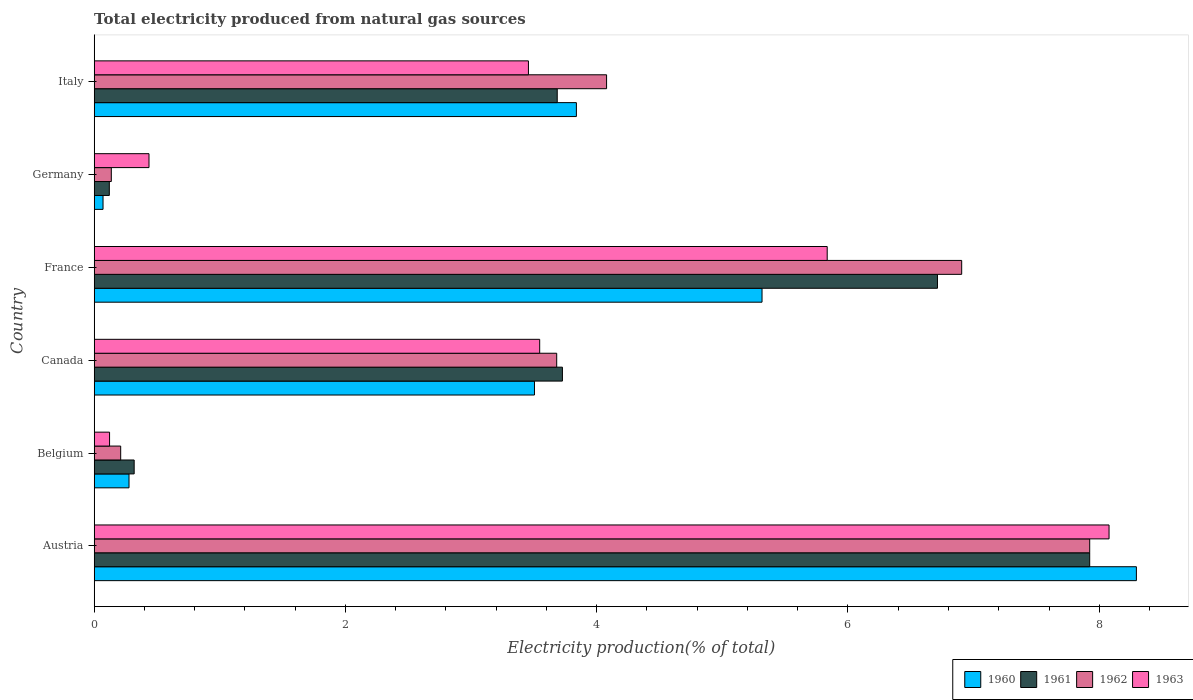How many different coloured bars are there?
Offer a terse response. 4. Are the number of bars per tick equal to the number of legend labels?
Ensure brevity in your answer.  Yes. Are the number of bars on each tick of the Y-axis equal?
Make the answer very short. Yes. In how many cases, is the number of bars for a given country not equal to the number of legend labels?
Provide a short and direct response. 0. What is the total electricity produced in 1963 in France?
Your answer should be very brief. 5.83. Across all countries, what is the maximum total electricity produced in 1962?
Offer a very short reply. 7.92. Across all countries, what is the minimum total electricity produced in 1961?
Offer a terse response. 0.12. What is the total total electricity produced in 1962 in the graph?
Offer a very short reply. 22.94. What is the difference between the total electricity produced in 1960 in Austria and that in Canada?
Keep it short and to the point. 4.79. What is the difference between the total electricity produced in 1963 in France and the total electricity produced in 1960 in Germany?
Your answer should be very brief. 5.76. What is the average total electricity produced in 1960 per country?
Your answer should be compact. 3.55. What is the difference between the total electricity produced in 1962 and total electricity produced in 1960 in Germany?
Provide a short and direct response. 0.07. What is the ratio of the total electricity produced in 1962 in Canada to that in Germany?
Your response must be concise. 27.02. Is the total electricity produced in 1960 in Canada less than that in Italy?
Offer a very short reply. Yes. What is the difference between the highest and the second highest total electricity produced in 1961?
Offer a terse response. 1.21. What is the difference between the highest and the lowest total electricity produced in 1963?
Give a very brief answer. 7.96. What does the 2nd bar from the bottom in Italy represents?
Provide a short and direct response. 1961. Is it the case that in every country, the sum of the total electricity produced in 1960 and total electricity produced in 1963 is greater than the total electricity produced in 1961?
Your response must be concise. Yes. How many countries are there in the graph?
Ensure brevity in your answer.  6. Does the graph contain any zero values?
Offer a terse response. No. How many legend labels are there?
Your answer should be very brief. 4. How are the legend labels stacked?
Ensure brevity in your answer.  Horizontal. What is the title of the graph?
Your answer should be compact. Total electricity produced from natural gas sources. What is the Electricity production(% of total) in 1960 in Austria?
Keep it short and to the point. 8.3. What is the Electricity production(% of total) in 1961 in Austria?
Ensure brevity in your answer.  7.92. What is the Electricity production(% of total) of 1962 in Austria?
Offer a very short reply. 7.92. What is the Electricity production(% of total) of 1963 in Austria?
Provide a succinct answer. 8.08. What is the Electricity production(% of total) in 1960 in Belgium?
Your response must be concise. 0.28. What is the Electricity production(% of total) of 1961 in Belgium?
Provide a succinct answer. 0.32. What is the Electricity production(% of total) in 1962 in Belgium?
Ensure brevity in your answer.  0.21. What is the Electricity production(% of total) in 1963 in Belgium?
Offer a very short reply. 0.12. What is the Electricity production(% of total) in 1960 in Canada?
Ensure brevity in your answer.  3.5. What is the Electricity production(% of total) of 1961 in Canada?
Make the answer very short. 3.73. What is the Electricity production(% of total) in 1962 in Canada?
Keep it short and to the point. 3.68. What is the Electricity production(% of total) of 1963 in Canada?
Offer a very short reply. 3.55. What is the Electricity production(% of total) of 1960 in France?
Keep it short and to the point. 5.32. What is the Electricity production(% of total) in 1961 in France?
Give a very brief answer. 6.71. What is the Electricity production(% of total) in 1962 in France?
Ensure brevity in your answer.  6.91. What is the Electricity production(% of total) in 1963 in France?
Ensure brevity in your answer.  5.83. What is the Electricity production(% of total) of 1960 in Germany?
Your response must be concise. 0.07. What is the Electricity production(% of total) in 1961 in Germany?
Keep it short and to the point. 0.12. What is the Electricity production(% of total) of 1962 in Germany?
Give a very brief answer. 0.14. What is the Electricity production(% of total) of 1963 in Germany?
Offer a very short reply. 0.44. What is the Electricity production(% of total) in 1960 in Italy?
Your answer should be very brief. 3.84. What is the Electricity production(% of total) of 1961 in Italy?
Ensure brevity in your answer.  3.69. What is the Electricity production(% of total) of 1962 in Italy?
Offer a terse response. 4.08. What is the Electricity production(% of total) of 1963 in Italy?
Ensure brevity in your answer.  3.46. Across all countries, what is the maximum Electricity production(% of total) in 1960?
Provide a succinct answer. 8.3. Across all countries, what is the maximum Electricity production(% of total) of 1961?
Your answer should be very brief. 7.92. Across all countries, what is the maximum Electricity production(% of total) in 1962?
Offer a terse response. 7.92. Across all countries, what is the maximum Electricity production(% of total) in 1963?
Provide a short and direct response. 8.08. Across all countries, what is the minimum Electricity production(% of total) in 1960?
Provide a short and direct response. 0.07. Across all countries, what is the minimum Electricity production(% of total) in 1961?
Provide a succinct answer. 0.12. Across all countries, what is the minimum Electricity production(% of total) in 1962?
Your answer should be compact. 0.14. Across all countries, what is the minimum Electricity production(% of total) of 1963?
Your answer should be compact. 0.12. What is the total Electricity production(% of total) in 1960 in the graph?
Make the answer very short. 21.3. What is the total Electricity production(% of total) in 1961 in the graph?
Offer a very short reply. 22.49. What is the total Electricity production(% of total) in 1962 in the graph?
Give a very brief answer. 22.94. What is the total Electricity production(% of total) in 1963 in the graph?
Your answer should be very brief. 21.47. What is the difference between the Electricity production(% of total) of 1960 in Austria and that in Belgium?
Make the answer very short. 8.02. What is the difference between the Electricity production(% of total) in 1961 in Austria and that in Belgium?
Ensure brevity in your answer.  7.61. What is the difference between the Electricity production(% of total) of 1962 in Austria and that in Belgium?
Your answer should be very brief. 7.71. What is the difference between the Electricity production(% of total) in 1963 in Austria and that in Belgium?
Give a very brief answer. 7.96. What is the difference between the Electricity production(% of total) in 1960 in Austria and that in Canada?
Your response must be concise. 4.79. What is the difference between the Electricity production(% of total) of 1961 in Austria and that in Canada?
Give a very brief answer. 4.2. What is the difference between the Electricity production(% of total) in 1962 in Austria and that in Canada?
Offer a terse response. 4.24. What is the difference between the Electricity production(% of total) in 1963 in Austria and that in Canada?
Ensure brevity in your answer.  4.53. What is the difference between the Electricity production(% of total) of 1960 in Austria and that in France?
Ensure brevity in your answer.  2.98. What is the difference between the Electricity production(% of total) in 1961 in Austria and that in France?
Provide a succinct answer. 1.21. What is the difference between the Electricity production(% of total) of 1962 in Austria and that in France?
Ensure brevity in your answer.  1.02. What is the difference between the Electricity production(% of total) of 1963 in Austria and that in France?
Offer a terse response. 2.24. What is the difference between the Electricity production(% of total) of 1960 in Austria and that in Germany?
Make the answer very short. 8.23. What is the difference between the Electricity production(% of total) in 1961 in Austria and that in Germany?
Give a very brief answer. 7.8. What is the difference between the Electricity production(% of total) of 1962 in Austria and that in Germany?
Give a very brief answer. 7.79. What is the difference between the Electricity production(% of total) in 1963 in Austria and that in Germany?
Offer a very short reply. 7.64. What is the difference between the Electricity production(% of total) of 1960 in Austria and that in Italy?
Give a very brief answer. 4.46. What is the difference between the Electricity production(% of total) of 1961 in Austria and that in Italy?
Make the answer very short. 4.24. What is the difference between the Electricity production(% of total) in 1962 in Austria and that in Italy?
Provide a succinct answer. 3.85. What is the difference between the Electricity production(% of total) of 1963 in Austria and that in Italy?
Your answer should be compact. 4.62. What is the difference between the Electricity production(% of total) in 1960 in Belgium and that in Canada?
Offer a terse response. -3.23. What is the difference between the Electricity production(% of total) of 1961 in Belgium and that in Canada?
Provide a succinct answer. -3.41. What is the difference between the Electricity production(% of total) in 1962 in Belgium and that in Canada?
Ensure brevity in your answer.  -3.47. What is the difference between the Electricity production(% of total) of 1963 in Belgium and that in Canada?
Make the answer very short. -3.42. What is the difference between the Electricity production(% of total) in 1960 in Belgium and that in France?
Offer a very short reply. -5.04. What is the difference between the Electricity production(% of total) in 1961 in Belgium and that in France?
Make the answer very short. -6.39. What is the difference between the Electricity production(% of total) in 1962 in Belgium and that in France?
Offer a very short reply. -6.69. What is the difference between the Electricity production(% of total) of 1963 in Belgium and that in France?
Your response must be concise. -5.71. What is the difference between the Electricity production(% of total) in 1960 in Belgium and that in Germany?
Provide a succinct answer. 0.21. What is the difference between the Electricity production(% of total) in 1961 in Belgium and that in Germany?
Your response must be concise. 0.2. What is the difference between the Electricity production(% of total) of 1962 in Belgium and that in Germany?
Provide a succinct answer. 0.07. What is the difference between the Electricity production(% of total) of 1963 in Belgium and that in Germany?
Offer a very short reply. -0.31. What is the difference between the Electricity production(% of total) of 1960 in Belgium and that in Italy?
Offer a very short reply. -3.56. What is the difference between the Electricity production(% of total) in 1961 in Belgium and that in Italy?
Your response must be concise. -3.37. What is the difference between the Electricity production(% of total) in 1962 in Belgium and that in Italy?
Your response must be concise. -3.87. What is the difference between the Electricity production(% of total) in 1963 in Belgium and that in Italy?
Offer a very short reply. -3.33. What is the difference between the Electricity production(% of total) of 1960 in Canada and that in France?
Your response must be concise. -1.81. What is the difference between the Electricity production(% of total) in 1961 in Canada and that in France?
Your answer should be very brief. -2.99. What is the difference between the Electricity production(% of total) in 1962 in Canada and that in France?
Provide a short and direct response. -3.22. What is the difference between the Electricity production(% of total) in 1963 in Canada and that in France?
Keep it short and to the point. -2.29. What is the difference between the Electricity production(% of total) in 1960 in Canada and that in Germany?
Your answer should be very brief. 3.43. What is the difference between the Electricity production(% of total) in 1961 in Canada and that in Germany?
Your response must be concise. 3.61. What is the difference between the Electricity production(% of total) of 1962 in Canada and that in Germany?
Give a very brief answer. 3.55. What is the difference between the Electricity production(% of total) in 1963 in Canada and that in Germany?
Your answer should be compact. 3.11. What is the difference between the Electricity production(% of total) of 1960 in Canada and that in Italy?
Make the answer very short. -0.33. What is the difference between the Electricity production(% of total) of 1961 in Canada and that in Italy?
Offer a very short reply. 0.04. What is the difference between the Electricity production(% of total) of 1962 in Canada and that in Italy?
Your answer should be very brief. -0.4. What is the difference between the Electricity production(% of total) in 1963 in Canada and that in Italy?
Keep it short and to the point. 0.09. What is the difference between the Electricity production(% of total) in 1960 in France and that in Germany?
Your answer should be very brief. 5.25. What is the difference between the Electricity production(% of total) of 1961 in France and that in Germany?
Ensure brevity in your answer.  6.59. What is the difference between the Electricity production(% of total) in 1962 in France and that in Germany?
Keep it short and to the point. 6.77. What is the difference between the Electricity production(% of total) in 1963 in France and that in Germany?
Your answer should be compact. 5.4. What is the difference between the Electricity production(% of total) of 1960 in France and that in Italy?
Your answer should be compact. 1.48. What is the difference between the Electricity production(% of total) of 1961 in France and that in Italy?
Your answer should be very brief. 3.03. What is the difference between the Electricity production(% of total) in 1962 in France and that in Italy?
Provide a succinct answer. 2.83. What is the difference between the Electricity production(% of total) in 1963 in France and that in Italy?
Offer a terse response. 2.38. What is the difference between the Electricity production(% of total) of 1960 in Germany and that in Italy?
Provide a succinct answer. -3.77. What is the difference between the Electricity production(% of total) in 1961 in Germany and that in Italy?
Give a very brief answer. -3.57. What is the difference between the Electricity production(% of total) of 1962 in Germany and that in Italy?
Provide a short and direct response. -3.94. What is the difference between the Electricity production(% of total) of 1963 in Germany and that in Italy?
Ensure brevity in your answer.  -3.02. What is the difference between the Electricity production(% of total) in 1960 in Austria and the Electricity production(% of total) in 1961 in Belgium?
Keep it short and to the point. 7.98. What is the difference between the Electricity production(% of total) in 1960 in Austria and the Electricity production(% of total) in 1962 in Belgium?
Provide a short and direct response. 8.08. What is the difference between the Electricity production(% of total) in 1960 in Austria and the Electricity production(% of total) in 1963 in Belgium?
Give a very brief answer. 8.17. What is the difference between the Electricity production(% of total) in 1961 in Austria and the Electricity production(% of total) in 1962 in Belgium?
Give a very brief answer. 7.71. What is the difference between the Electricity production(% of total) of 1961 in Austria and the Electricity production(% of total) of 1963 in Belgium?
Your answer should be compact. 7.8. What is the difference between the Electricity production(% of total) of 1962 in Austria and the Electricity production(% of total) of 1963 in Belgium?
Ensure brevity in your answer.  7.8. What is the difference between the Electricity production(% of total) in 1960 in Austria and the Electricity production(% of total) in 1961 in Canada?
Provide a succinct answer. 4.57. What is the difference between the Electricity production(% of total) in 1960 in Austria and the Electricity production(% of total) in 1962 in Canada?
Provide a short and direct response. 4.61. What is the difference between the Electricity production(% of total) in 1960 in Austria and the Electricity production(% of total) in 1963 in Canada?
Keep it short and to the point. 4.75. What is the difference between the Electricity production(% of total) of 1961 in Austria and the Electricity production(% of total) of 1962 in Canada?
Your answer should be very brief. 4.24. What is the difference between the Electricity production(% of total) of 1961 in Austria and the Electricity production(% of total) of 1963 in Canada?
Make the answer very short. 4.38. What is the difference between the Electricity production(% of total) in 1962 in Austria and the Electricity production(% of total) in 1963 in Canada?
Your response must be concise. 4.38. What is the difference between the Electricity production(% of total) of 1960 in Austria and the Electricity production(% of total) of 1961 in France?
Provide a succinct answer. 1.58. What is the difference between the Electricity production(% of total) of 1960 in Austria and the Electricity production(% of total) of 1962 in France?
Give a very brief answer. 1.39. What is the difference between the Electricity production(% of total) in 1960 in Austria and the Electricity production(% of total) in 1963 in France?
Offer a very short reply. 2.46. What is the difference between the Electricity production(% of total) in 1961 in Austria and the Electricity production(% of total) in 1962 in France?
Ensure brevity in your answer.  1.02. What is the difference between the Electricity production(% of total) of 1961 in Austria and the Electricity production(% of total) of 1963 in France?
Your response must be concise. 2.09. What is the difference between the Electricity production(% of total) of 1962 in Austria and the Electricity production(% of total) of 1963 in France?
Make the answer very short. 2.09. What is the difference between the Electricity production(% of total) of 1960 in Austria and the Electricity production(% of total) of 1961 in Germany?
Your answer should be compact. 8.18. What is the difference between the Electricity production(% of total) in 1960 in Austria and the Electricity production(% of total) in 1962 in Germany?
Make the answer very short. 8.16. What is the difference between the Electricity production(% of total) in 1960 in Austria and the Electricity production(% of total) in 1963 in Germany?
Your response must be concise. 7.86. What is the difference between the Electricity production(% of total) of 1961 in Austria and the Electricity production(% of total) of 1962 in Germany?
Your response must be concise. 7.79. What is the difference between the Electricity production(% of total) of 1961 in Austria and the Electricity production(% of total) of 1963 in Germany?
Provide a succinct answer. 7.49. What is the difference between the Electricity production(% of total) of 1962 in Austria and the Electricity production(% of total) of 1963 in Germany?
Give a very brief answer. 7.49. What is the difference between the Electricity production(% of total) in 1960 in Austria and the Electricity production(% of total) in 1961 in Italy?
Offer a terse response. 4.61. What is the difference between the Electricity production(% of total) of 1960 in Austria and the Electricity production(% of total) of 1962 in Italy?
Provide a succinct answer. 4.22. What is the difference between the Electricity production(% of total) of 1960 in Austria and the Electricity production(% of total) of 1963 in Italy?
Ensure brevity in your answer.  4.84. What is the difference between the Electricity production(% of total) in 1961 in Austria and the Electricity production(% of total) in 1962 in Italy?
Ensure brevity in your answer.  3.85. What is the difference between the Electricity production(% of total) in 1961 in Austria and the Electricity production(% of total) in 1963 in Italy?
Offer a terse response. 4.47. What is the difference between the Electricity production(% of total) of 1962 in Austria and the Electricity production(% of total) of 1963 in Italy?
Your answer should be very brief. 4.47. What is the difference between the Electricity production(% of total) in 1960 in Belgium and the Electricity production(% of total) in 1961 in Canada?
Your answer should be compact. -3.45. What is the difference between the Electricity production(% of total) of 1960 in Belgium and the Electricity production(% of total) of 1962 in Canada?
Your answer should be compact. -3.4. What is the difference between the Electricity production(% of total) of 1960 in Belgium and the Electricity production(% of total) of 1963 in Canada?
Your answer should be very brief. -3.27. What is the difference between the Electricity production(% of total) in 1961 in Belgium and the Electricity production(% of total) in 1962 in Canada?
Your answer should be compact. -3.36. What is the difference between the Electricity production(% of total) of 1961 in Belgium and the Electricity production(% of total) of 1963 in Canada?
Offer a terse response. -3.23. What is the difference between the Electricity production(% of total) in 1962 in Belgium and the Electricity production(% of total) in 1963 in Canada?
Your answer should be compact. -3.34. What is the difference between the Electricity production(% of total) in 1960 in Belgium and the Electricity production(% of total) in 1961 in France?
Make the answer very short. -6.43. What is the difference between the Electricity production(% of total) in 1960 in Belgium and the Electricity production(% of total) in 1962 in France?
Offer a terse response. -6.63. What is the difference between the Electricity production(% of total) of 1960 in Belgium and the Electricity production(% of total) of 1963 in France?
Keep it short and to the point. -5.56. What is the difference between the Electricity production(% of total) of 1961 in Belgium and the Electricity production(% of total) of 1962 in France?
Ensure brevity in your answer.  -6.59. What is the difference between the Electricity production(% of total) in 1961 in Belgium and the Electricity production(% of total) in 1963 in France?
Your answer should be compact. -5.52. What is the difference between the Electricity production(% of total) in 1962 in Belgium and the Electricity production(% of total) in 1963 in France?
Your answer should be very brief. -5.62. What is the difference between the Electricity production(% of total) of 1960 in Belgium and the Electricity production(% of total) of 1961 in Germany?
Your answer should be compact. 0.16. What is the difference between the Electricity production(% of total) of 1960 in Belgium and the Electricity production(% of total) of 1962 in Germany?
Your answer should be compact. 0.14. What is the difference between the Electricity production(% of total) of 1960 in Belgium and the Electricity production(% of total) of 1963 in Germany?
Your response must be concise. -0.16. What is the difference between the Electricity production(% of total) in 1961 in Belgium and the Electricity production(% of total) in 1962 in Germany?
Offer a terse response. 0.18. What is the difference between the Electricity production(% of total) in 1961 in Belgium and the Electricity production(% of total) in 1963 in Germany?
Provide a succinct answer. -0.12. What is the difference between the Electricity production(% of total) of 1962 in Belgium and the Electricity production(% of total) of 1963 in Germany?
Offer a terse response. -0.23. What is the difference between the Electricity production(% of total) in 1960 in Belgium and the Electricity production(% of total) in 1961 in Italy?
Your answer should be very brief. -3.41. What is the difference between the Electricity production(% of total) of 1960 in Belgium and the Electricity production(% of total) of 1962 in Italy?
Ensure brevity in your answer.  -3.8. What is the difference between the Electricity production(% of total) of 1960 in Belgium and the Electricity production(% of total) of 1963 in Italy?
Offer a terse response. -3.18. What is the difference between the Electricity production(% of total) of 1961 in Belgium and the Electricity production(% of total) of 1962 in Italy?
Provide a succinct answer. -3.76. What is the difference between the Electricity production(% of total) in 1961 in Belgium and the Electricity production(% of total) in 1963 in Italy?
Your response must be concise. -3.14. What is the difference between the Electricity production(% of total) of 1962 in Belgium and the Electricity production(% of total) of 1963 in Italy?
Give a very brief answer. -3.25. What is the difference between the Electricity production(% of total) of 1960 in Canada and the Electricity production(% of total) of 1961 in France?
Give a very brief answer. -3.21. What is the difference between the Electricity production(% of total) of 1960 in Canada and the Electricity production(% of total) of 1962 in France?
Your answer should be very brief. -3.4. What is the difference between the Electricity production(% of total) in 1960 in Canada and the Electricity production(% of total) in 1963 in France?
Make the answer very short. -2.33. What is the difference between the Electricity production(% of total) in 1961 in Canada and the Electricity production(% of total) in 1962 in France?
Give a very brief answer. -3.18. What is the difference between the Electricity production(% of total) of 1961 in Canada and the Electricity production(% of total) of 1963 in France?
Your answer should be compact. -2.11. What is the difference between the Electricity production(% of total) of 1962 in Canada and the Electricity production(% of total) of 1963 in France?
Your answer should be compact. -2.15. What is the difference between the Electricity production(% of total) of 1960 in Canada and the Electricity production(% of total) of 1961 in Germany?
Your response must be concise. 3.38. What is the difference between the Electricity production(% of total) in 1960 in Canada and the Electricity production(% of total) in 1962 in Germany?
Keep it short and to the point. 3.37. What is the difference between the Electricity production(% of total) of 1960 in Canada and the Electricity production(% of total) of 1963 in Germany?
Your answer should be very brief. 3.07. What is the difference between the Electricity production(% of total) of 1961 in Canada and the Electricity production(% of total) of 1962 in Germany?
Keep it short and to the point. 3.59. What is the difference between the Electricity production(% of total) of 1961 in Canada and the Electricity production(% of total) of 1963 in Germany?
Ensure brevity in your answer.  3.29. What is the difference between the Electricity production(% of total) in 1962 in Canada and the Electricity production(% of total) in 1963 in Germany?
Make the answer very short. 3.25. What is the difference between the Electricity production(% of total) of 1960 in Canada and the Electricity production(% of total) of 1961 in Italy?
Your answer should be compact. -0.18. What is the difference between the Electricity production(% of total) in 1960 in Canada and the Electricity production(% of total) in 1962 in Italy?
Provide a short and direct response. -0.57. What is the difference between the Electricity production(% of total) in 1960 in Canada and the Electricity production(% of total) in 1963 in Italy?
Offer a very short reply. 0.05. What is the difference between the Electricity production(% of total) in 1961 in Canada and the Electricity production(% of total) in 1962 in Italy?
Your answer should be very brief. -0.35. What is the difference between the Electricity production(% of total) in 1961 in Canada and the Electricity production(% of total) in 1963 in Italy?
Offer a terse response. 0.27. What is the difference between the Electricity production(% of total) of 1962 in Canada and the Electricity production(% of total) of 1963 in Italy?
Your answer should be compact. 0.23. What is the difference between the Electricity production(% of total) of 1960 in France and the Electricity production(% of total) of 1961 in Germany?
Offer a very short reply. 5.2. What is the difference between the Electricity production(% of total) in 1960 in France and the Electricity production(% of total) in 1962 in Germany?
Your response must be concise. 5.18. What is the difference between the Electricity production(% of total) in 1960 in France and the Electricity production(% of total) in 1963 in Germany?
Provide a short and direct response. 4.88. What is the difference between the Electricity production(% of total) in 1961 in France and the Electricity production(% of total) in 1962 in Germany?
Your answer should be compact. 6.58. What is the difference between the Electricity production(% of total) of 1961 in France and the Electricity production(% of total) of 1963 in Germany?
Give a very brief answer. 6.28. What is the difference between the Electricity production(% of total) of 1962 in France and the Electricity production(% of total) of 1963 in Germany?
Offer a terse response. 6.47. What is the difference between the Electricity production(% of total) of 1960 in France and the Electricity production(% of total) of 1961 in Italy?
Your response must be concise. 1.63. What is the difference between the Electricity production(% of total) in 1960 in France and the Electricity production(% of total) in 1962 in Italy?
Offer a terse response. 1.24. What is the difference between the Electricity production(% of total) of 1960 in France and the Electricity production(% of total) of 1963 in Italy?
Give a very brief answer. 1.86. What is the difference between the Electricity production(% of total) in 1961 in France and the Electricity production(% of total) in 1962 in Italy?
Your answer should be compact. 2.63. What is the difference between the Electricity production(% of total) in 1961 in France and the Electricity production(% of total) in 1963 in Italy?
Keep it short and to the point. 3.26. What is the difference between the Electricity production(% of total) of 1962 in France and the Electricity production(% of total) of 1963 in Italy?
Your response must be concise. 3.45. What is the difference between the Electricity production(% of total) of 1960 in Germany and the Electricity production(% of total) of 1961 in Italy?
Ensure brevity in your answer.  -3.62. What is the difference between the Electricity production(% of total) of 1960 in Germany and the Electricity production(% of total) of 1962 in Italy?
Your answer should be compact. -4.01. What is the difference between the Electricity production(% of total) of 1960 in Germany and the Electricity production(% of total) of 1963 in Italy?
Your response must be concise. -3.39. What is the difference between the Electricity production(% of total) of 1961 in Germany and the Electricity production(% of total) of 1962 in Italy?
Provide a short and direct response. -3.96. What is the difference between the Electricity production(% of total) of 1961 in Germany and the Electricity production(% of total) of 1963 in Italy?
Offer a terse response. -3.34. What is the difference between the Electricity production(% of total) of 1962 in Germany and the Electricity production(% of total) of 1963 in Italy?
Make the answer very short. -3.32. What is the average Electricity production(% of total) of 1960 per country?
Your answer should be compact. 3.55. What is the average Electricity production(% of total) in 1961 per country?
Provide a short and direct response. 3.75. What is the average Electricity production(% of total) in 1962 per country?
Keep it short and to the point. 3.82. What is the average Electricity production(% of total) in 1963 per country?
Give a very brief answer. 3.58. What is the difference between the Electricity production(% of total) in 1960 and Electricity production(% of total) in 1961 in Austria?
Your response must be concise. 0.37. What is the difference between the Electricity production(% of total) in 1960 and Electricity production(% of total) in 1962 in Austria?
Your answer should be very brief. 0.37. What is the difference between the Electricity production(% of total) in 1960 and Electricity production(% of total) in 1963 in Austria?
Your answer should be very brief. 0.22. What is the difference between the Electricity production(% of total) of 1961 and Electricity production(% of total) of 1963 in Austria?
Offer a very short reply. -0.15. What is the difference between the Electricity production(% of total) of 1962 and Electricity production(% of total) of 1963 in Austria?
Ensure brevity in your answer.  -0.15. What is the difference between the Electricity production(% of total) of 1960 and Electricity production(% of total) of 1961 in Belgium?
Ensure brevity in your answer.  -0.04. What is the difference between the Electricity production(% of total) of 1960 and Electricity production(% of total) of 1962 in Belgium?
Ensure brevity in your answer.  0.07. What is the difference between the Electricity production(% of total) in 1960 and Electricity production(% of total) in 1963 in Belgium?
Provide a short and direct response. 0.15. What is the difference between the Electricity production(% of total) in 1961 and Electricity production(% of total) in 1962 in Belgium?
Provide a short and direct response. 0.11. What is the difference between the Electricity production(% of total) of 1961 and Electricity production(% of total) of 1963 in Belgium?
Give a very brief answer. 0.2. What is the difference between the Electricity production(% of total) in 1962 and Electricity production(% of total) in 1963 in Belgium?
Provide a short and direct response. 0.09. What is the difference between the Electricity production(% of total) of 1960 and Electricity production(% of total) of 1961 in Canada?
Ensure brevity in your answer.  -0.22. What is the difference between the Electricity production(% of total) in 1960 and Electricity production(% of total) in 1962 in Canada?
Offer a very short reply. -0.18. What is the difference between the Electricity production(% of total) of 1960 and Electricity production(% of total) of 1963 in Canada?
Keep it short and to the point. -0.04. What is the difference between the Electricity production(% of total) in 1961 and Electricity production(% of total) in 1962 in Canada?
Make the answer very short. 0.05. What is the difference between the Electricity production(% of total) of 1961 and Electricity production(% of total) of 1963 in Canada?
Your answer should be very brief. 0.18. What is the difference between the Electricity production(% of total) in 1962 and Electricity production(% of total) in 1963 in Canada?
Your response must be concise. 0.14. What is the difference between the Electricity production(% of total) in 1960 and Electricity production(% of total) in 1961 in France?
Offer a very short reply. -1.4. What is the difference between the Electricity production(% of total) in 1960 and Electricity production(% of total) in 1962 in France?
Ensure brevity in your answer.  -1.59. What is the difference between the Electricity production(% of total) in 1960 and Electricity production(% of total) in 1963 in France?
Provide a succinct answer. -0.52. What is the difference between the Electricity production(% of total) in 1961 and Electricity production(% of total) in 1962 in France?
Offer a terse response. -0.19. What is the difference between the Electricity production(% of total) of 1961 and Electricity production(% of total) of 1963 in France?
Keep it short and to the point. 0.88. What is the difference between the Electricity production(% of total) of 1962 and Electricity production(% of total) of 1963 in France?
Ensure brevity in your answer.  1.07. What is the difference between the Electricity production(% of total) of 1960 and Electricity production(% of total) of 1961 in Germany?
Your response must be concise. -0.05. What is the difference between the Electricity production(% of total) in 1960 and Electricity production(% of total) in 1962 in Germany?
Give a very brief answer. -0.07. What is the difference between the Electricity production(% of total) of 1960 and Electricity production(% of total) of 1963 in Germany?
Offer a very short reply. -0.37. What is the difference between the Electricity production(% of total) in 1961 and Electricity production(% of total) in 1962 in Germany?
Provide a succinct answer. -0.02. What is the difference between the Electricity production(% of total) of 1961 and Electricity production(% of total) of 1963 in Germany?
Offer a terse response. -0.32. What is the difference between the Electricity production(% of total) of 1962 and Electricity production(% of total) of 1963 in Germany?
Give a very brief answer. -0.3. What is the difference between the Electricity production(% of total) in 1960 and Electricity production(% of total) in 1961 in Italy?
Ensure brevity in your answer.  0.15. What is the difference between the Electricity production(% of total) in 1960 and Electricity production(% of total) in 1962 in Italy?
Give a very brief answer. -0.24. What is the difference between the Electricity production(% of total) in 1960 and Electricity production(% of total) in 1963 in Italy?
Offer a terse response. 0.38. What is the difference between the Electricity production(% of total) of 1961 and Electricity production(% of total) of 1962 in Italy?
Keep it short and to the point. -0.39. What is the difference between the Electricity production(% of total) in 1961 and Electricity production(% of total) in 1963 in Italy?
Provide a succinct answer. 0.23. What is the difference between the Electricity production(% of total) in 1962 and Electricity production(% of total) in 1963 in Italy?
Ensure brevity in your answer.  0.62. What is the ratio of the Electricity production(% of total) of 1960 in Austria to that in Belgium?
Make the answer very short. 29.93. What is the ratio of the Electricity production(% of total) in 1961 in Austria to that in Belgium?
Your response must be concise. 24.9. What is the ratio of the Electricity production(% of total) of 1962 in Austria to that in Belgium?
Offer a very short reply. 37.57. What is the ratio of the Electricity production(% of total) of 1963 in Austria to that in Belgium?
Keep it short and to the point. 66.07. What is the ratio of the Electricity production(% of total) in 1960 in Austria to that in Canada?
Offer a terse response. 2.37. What is the ratio of the Electricity production(% of total) of 1961 in Austria to that in Canada?
Make the answer very short. 2.13. What is the ratio of the Electricity production(% of total) in 1962 in Austria to that in Canada?
Give a very brief answer. 2.15. What is the ratio of the Electricity production(% of total) in 1963 in Austria to that in Canada?
Your response must be concise. 2.28. What is the ratio of the Electricity production(% of total) in 1960 in Austria to that in France?
Make the answer very short. 1.56. What is the ratio of the Electricity production(% of total) of 1961 in Austria to that in France?
Offer a terse response. 1.18. What is the ratio of the Electricity production(% of total) of 1962 in Austria to that in France?
Make the answer very short. 1.15. What is the ratio of the Electricity production(% of total) of 1963 in Austria to that in France?
Offer a very short reply. 1.38. What is the ratio of the Electricity production(% of total) in 1960 in Austria to that in Germany?
Offer a terse response. 118.01. What is the ratio of the Electricity production(% of total) in 1961 in Austria to that in Germany?
Your answer should be very brief. 65.86. What is the ratio of the Electricity production(% of total) in 1962 in Austria to that in Germany?
Your response must be concise. 58.17. What is the ratio of the Electricity production(% of total) of 1963 in Austria to that in Germany?
Make the answer very short. 18.52. What is the ratio of the Electricity production(% of total) of 1960 in Austria to that in Italy?
Offer a very short reply. 2.16. What is the ratio of the Electricity production(% of total) of 1961 in Austria to that in Italy?
Make the answer very short. 2.15. What is the ratio of the Electricity production(% of total) in 1962 in Austria to that in Italy?
Your answer should be very brief. 1.94. What is the ratio of the Electricity production(% of total) of 1963 in Austria to that in Italy?
Offer a terse response. 2.34. What is the ratio of the Electricity production(% of total) of 1960 in Belgium to that in Canada?
Give a very brief answer. 0.08. What is the ratio of the Electricity production(% of total) of 1961 in Belgium to that in Canada?
Make the answer very short. 0.09. What is the ratio of the Electricity production(% of total) in 1962 in Belgium to that in Canada?
Provide a short and direct response. 0.06. What is the ratio of the Electricity production(% of total) of 1963 in Belgium to that in Canada?
Make the answer very short. 0.03. What is the ratio of the Electricity production(% of total) in 1960 in Belgium to that in France?
Your answer should be very brief. 0.05. What is the ratio of the Electricity production(% of total) in 1961 in Belgium to that in France?
Ensure brevity in your answer.  0.05. What is the ratio of the Electricity production(% of total) of 1962 in Belgium to that in France?
Keep it short and to the point. 0.03. What is the ratio of the Electricity production(% of total) in 1963 in Belgium to that in France?
Your answer should be compact. 0.02. What is the ratio of the Electricity production(% of total) of 1960 in Belgium to that in Germany?
Ensure brevity in your answer.  3.94. What is the ratio of the Electricity production(% of total) in 1961 in Belgium to that in Germany?
Keep it short and to the point. 2.64. What is the ratio of the Electricity production(% of total) in 1962 in Belgium to that in Germany?
Your response must be concise. 1.55. What is the ratio of the Electricity production(% of total) of 1963 in Belgium to that in Germany?
Ensure brevity in your answer.  0.28. What is the ratio of the Electricity production(% of total) of 1960 in Belgium to that in Italy?
Your response must be concise. 0.07. What is the ratio of the Electricity production(% of total) of 1961 in Belgium to that in Italy?
Make the answer very short. 0.09. What is the ratio of the Electricity production(% of total) in 1962 in Belgium to that in Italy?
Offer a terse response. 0.05. What is the ratio of the Electricity production(% of total) of 1963 in Belgium to that in Italy?
Provide a short and direct response. 0.04. What is the ratio of the Electricity production(% of total) of 1960 in Canada to that in France?
Offer a very short reply. 0.66. What is the ratio of the Electricity production(% of total) of 1961 in Canada to that in France?
Your answer should be compact. 0.56. What is the ratio of the Electricity production(% of total) in 1962 in Canada to that in France?
Give a very brief answer. 0.53. What is the ratio of the Electricity production(% of total) of 1963 in Canada to that in France?
Provide a short and direct response. 0.61. What is the ratio of the Electricity production(% of total) of 1960 in Canada to that in Germany?
Make the answer very short. 49.85. What is the ratio of the Electricity production(% of total) of 1961 in Canada to that in Germany?
Provide a short and direct response. 30.98. What is the ratio of the Electricity production(% of total) of 1962 in Canada to that in Germany?
Provide a succinct answer. 27.02. What is the ratio of the Electricity production(% of total) of 1963 in Canada to that in Germany?
Give a very brief answer. 8.13. What is the ratio of the Electricity production(% of total) of 1960 in Canada to that in Italy?
Keep it short and to the point. 0.91. What is the ratio of the Electricity production(% of total) in 1961 in Canada to that in Italy?
Ensure brevity in your answer.  1.01. What is the ratio of the Electricity production(% of total) of 1962 in Canada to that in Italy?
Make the answer very short. 0.9. What is the ratio of the Electricity production(% of total) of 1963 in Canada to that in Italy?
Provide a succinct answer. 1.03. What is the ratio of the Electricity production(% of total) in 1960 in France to that in Germany?
Offer a very short reply. 75.62. What is the ratio of the Electricity production(% of total) in 1961 in France to that in Germany?
Keep it short and to the point. 55.79. What is the ratio of the Electricity production(% of total) in 1962 in France to that in Germany?
Provide a short and direct response. 50.69. What is the ratio of the Electricity production(% of total) of 1963 in France to that in Germany?
Make the answer very short. 13.38. What is the ratio of the Electricity production(% of total) in 1960 in France to that in Italy?
Ensure brevity in your answer.  1.39. What is the ratio of the Electricity production(% of total) in 1961 in France to that in Italy?
Ensure brevity in your answer.  1.82. What is the ratio of the Electricity production(% of total) in 1962 in France to that in Italy?
Give a very brief answer. 1.69. What is the ratio of the Electricity production(% of total) in 1963 in France to that in Italy?
Your answer should be compact. 1.69. What is the ratio of the Electricity production(% of total) of 1960 in Germany to that in Italy?
Give a very brief answer. 0.02. What is the ratio of the Electricity production(% of total) in 1961 in Germany to that in Italy?
Keep it short and to the point. 0.03. What is the ratio of the Electricity production(% of total) in 1962 in Germany to that in Italy?
Provide a short and direct response. 0.03. What is the ratio of the Electricity production(% of total) in 1963 in Germany to that in Italy?
Give a very brief answer. 0.13. What is the difference between the highest and the second highest Electricity production(% of total) in 1960?
Your answer should be very brief. 2.98. What is the difference between the highest and the second highest Electricity production(% of total) in 1961?
Make the answer very short. 1.21. What is the difference between the highest and the second highest Electricity production(% of total) of 1963?
Your response must be concise. 2.24. What is the difference between the highest and the lowest Electricity production(% of total) of 1960?
Your answer should be very brief. 8.23. What is the difference between the highest and the lowest Electricity production(% of total) in 1961?
Offer a very short reply. 7.8. What is the difference between the highest and the lowest Electricity production(% of total) in 1962?
Your answer should be compact. 7.79. What is the difference between the highest and the lowest Electricity production(% of total) of 1963?
Your response must be concise. 7.96. 